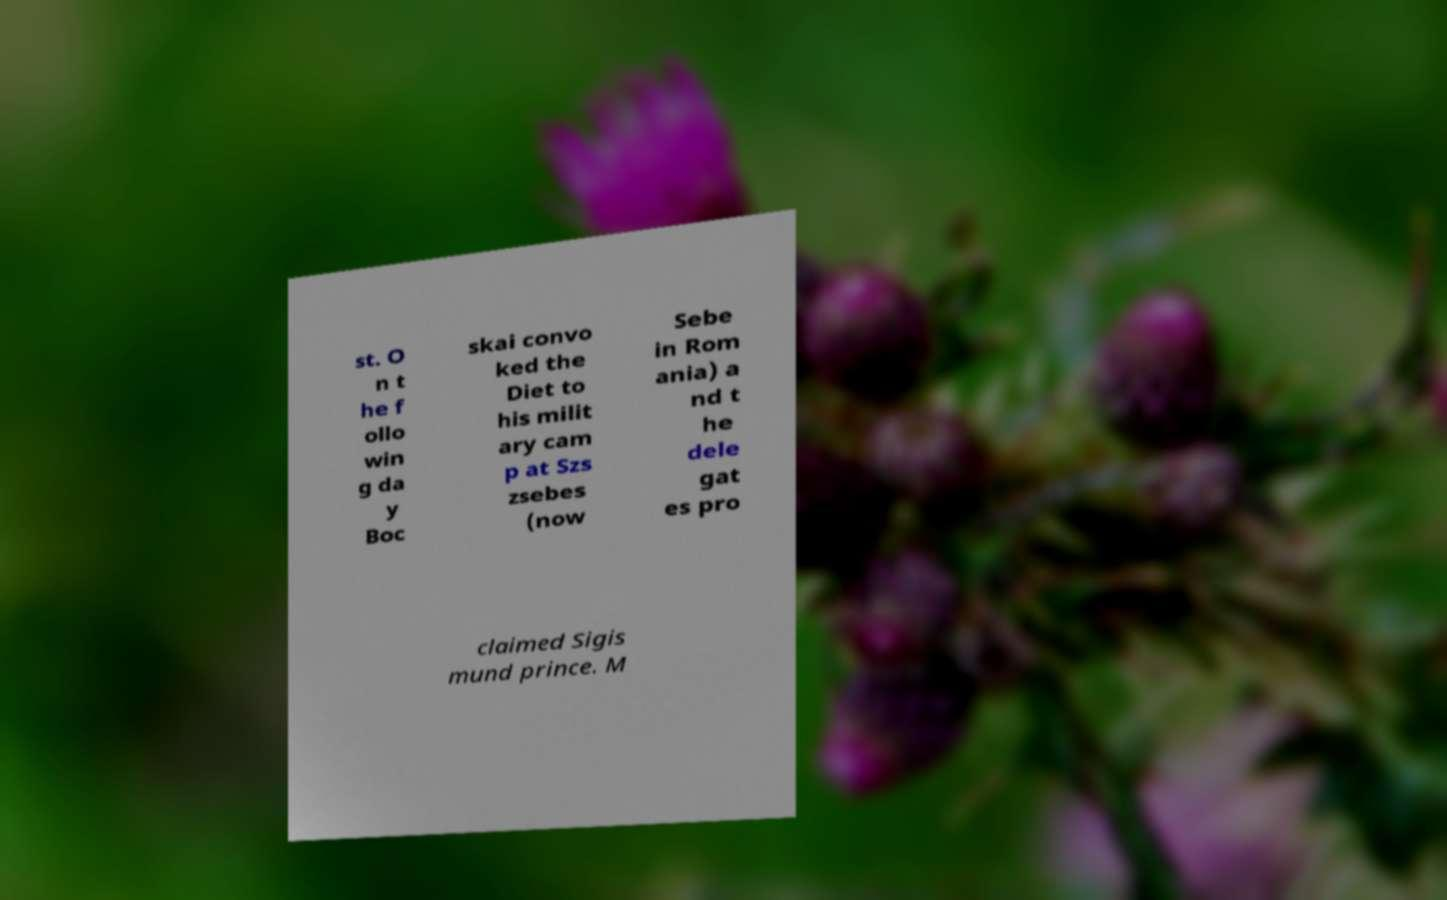Can you accurately transcribe the text from the provided image for me? st. O n t he f ollo win g da y Boc skai convo ked the Diet to his milit ary cam p at Szs zsebes (now Sebe in Rom ania) a nd t he dele gat es pro claimed Sigis mund prince. M 